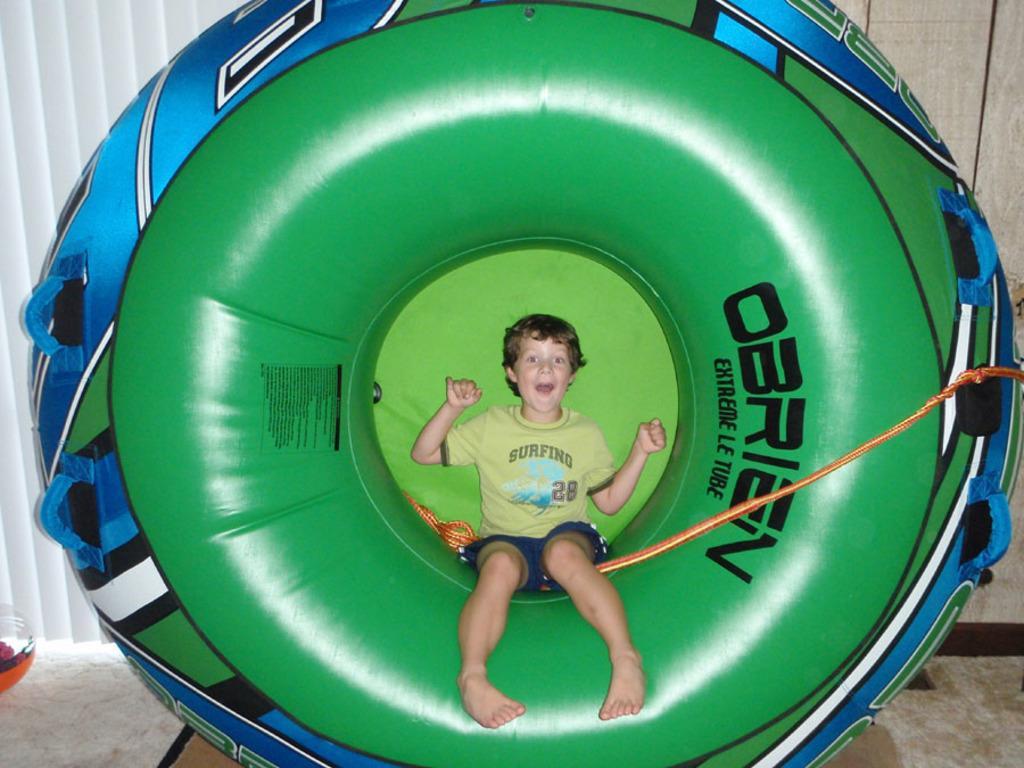Could you give a brief overview of what you see in this image? In the center of the image we can see an inflatable tube with some text on it. On the tube, we can see one kid is sitting and he is smiling. And we can see the wire type object is attached to the tube. In the background there is a wooden wall, curtain and a few other objects. 